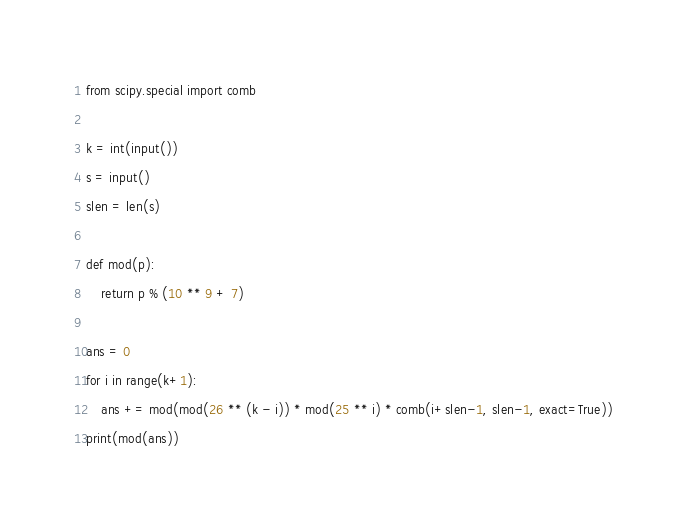Convert code to text. <code><loc_0><loc_0><loc_500><loc_500><_Python_>from scipy.special import comb

k = int(input())
s = input()
slen = len(s)

def mod(p):
    return p % (10 ** 9 + 7)

ans = 0
for i in range(k+1):
    ans += mod(mod(26 ** (k - i)) * mod(25 ** i) * comb(i+slen-1, slen-1, exact=True))
print(mod(ans))</code> 